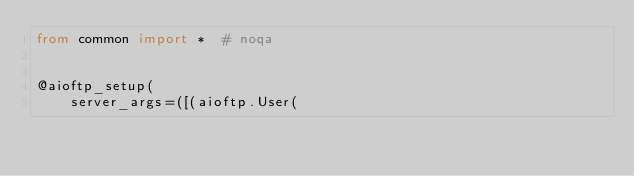Convert code to text. <code><loc_0><loc_0><loc_500><loc_500><_Python_>from common import *  # noqa


@aioftp_setup(
    server_args=([(aioftp.User(</code> 